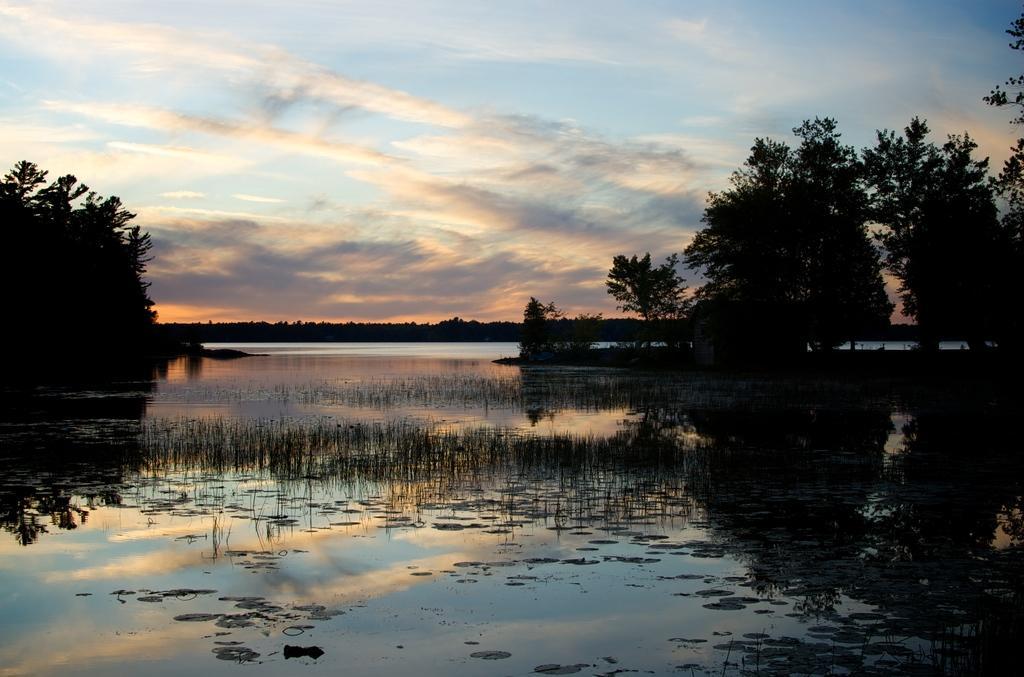In one or two sentences, can you explain what this image depicts? In this picture I can see the water in the middle. There are trees on either side of this image, at the top I can see the sky. 